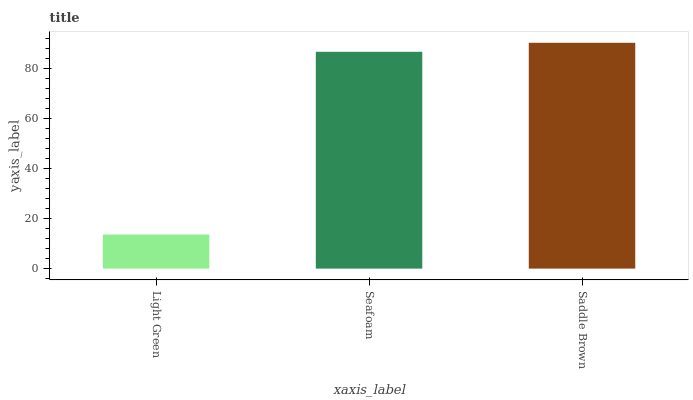Is Seafoam the minimum?
Answer yes or no. No. Is Seafoam the maximum?
Answer yes or no. No. Is Seafoam greater than Light Green?
Answer yes or no. Yes. Is Light Green less than Seafoam?
Answer yes or no. Yes. Is Light Green greater than Seafoam?
Answer yes or no. No. Is Seafoam less than Light Green?
Answer yes or no. No. Is Seafoam the high median?
Answer yes or no. Yes. Is Seafoam the low median?
Answer yes or no. Yes. Is Saddle Brown the high median?
Answer yes or no. No. Is Saddle Brown the low median?
Answer yes or no. No. 